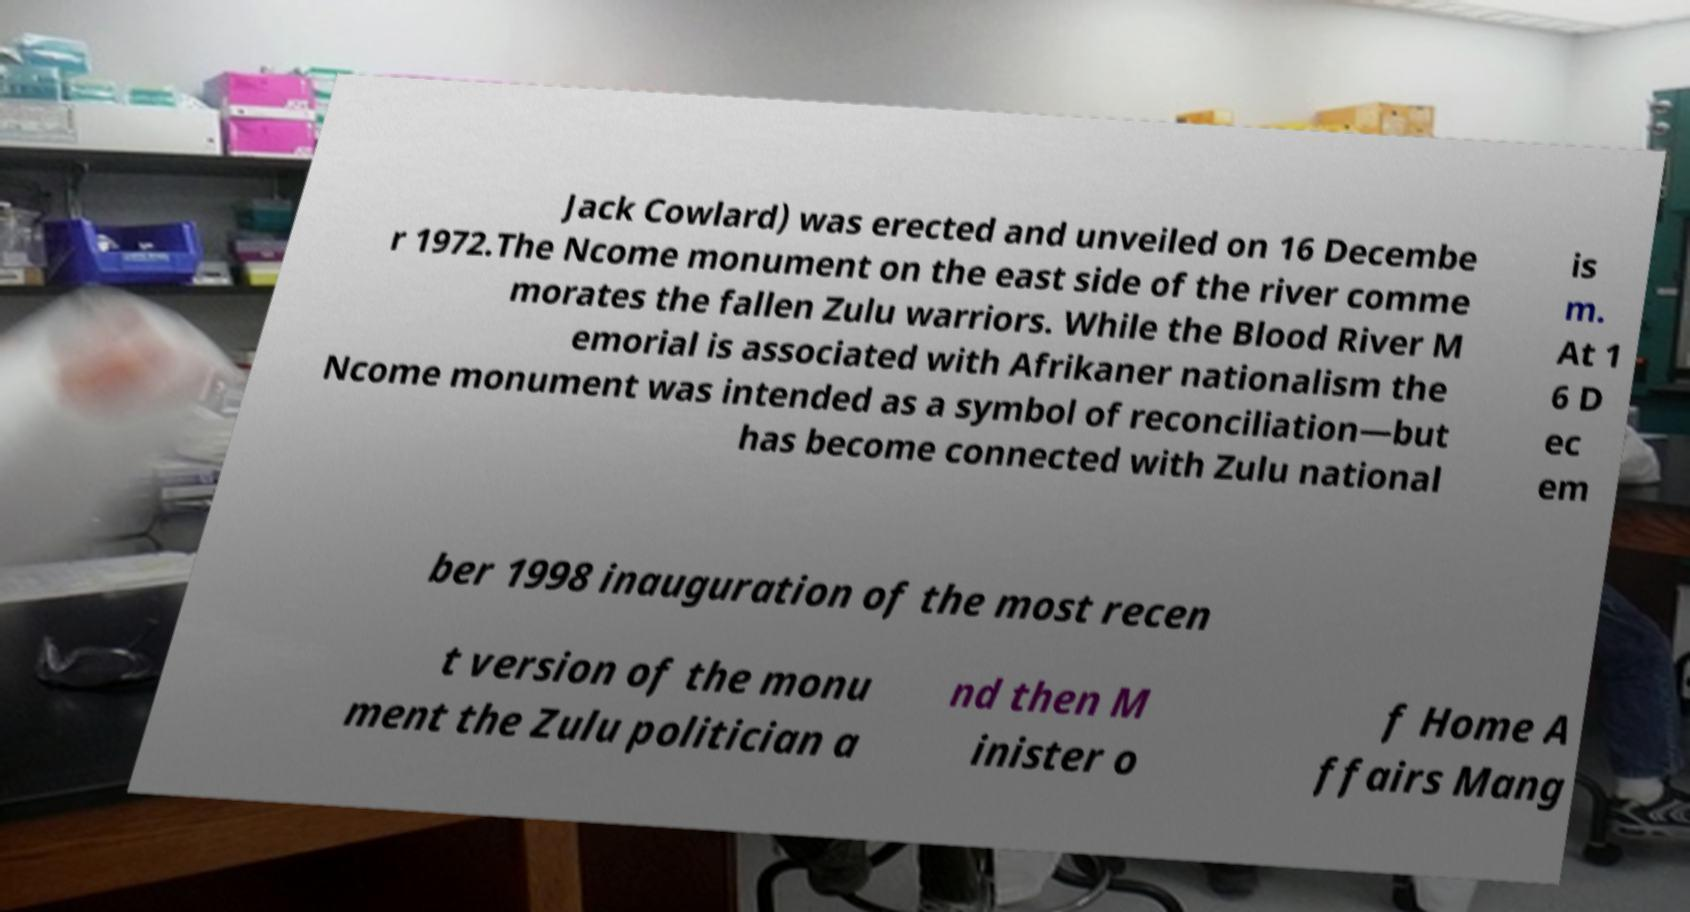Could you extract and type out the text from this image? Jack Cowlard) was erected and unveiled on 16 Decembe r 1972.The Ncome monument on the east side of the river comme morates the fallen Zulu warriors. While the Blood River M emorial is associated with Afrikaner nationalism the Ncome monument was intended as a symbol of reconciliation—but has become connected with Zulu national is m. At 1 6 D ec em ber 1998 inauguration of the most recen t version of the monu ment the Zulu politician a nd then M inister o f Home A ffairs Mang 